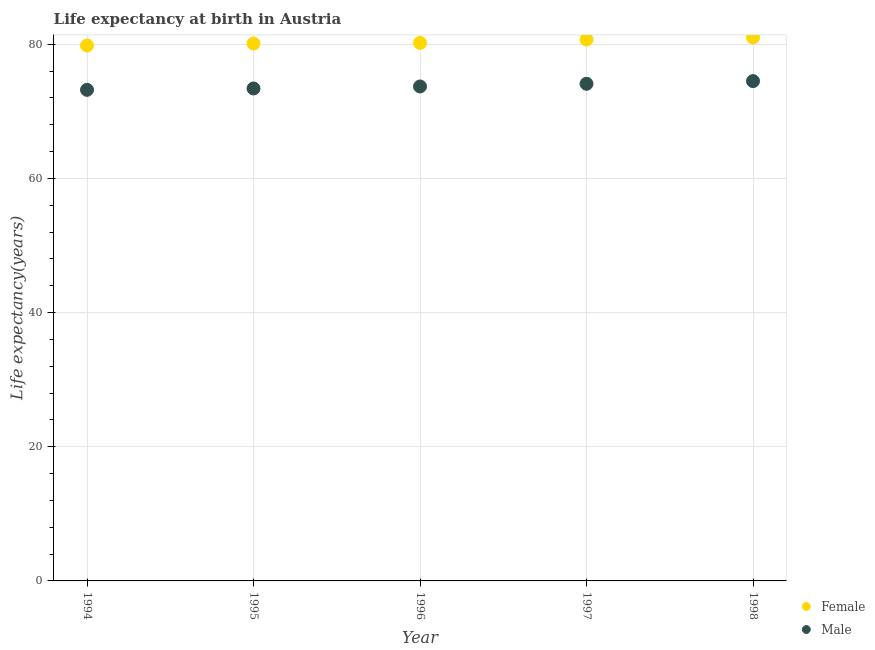How many different coloured dotlines are there?
Ensure brevity in your answer.  2. Across all years, what is the minimum life expectancy(female)?
Ensure brevity in your answer.  79.8. In which year was the life expectancy(female) maximum?
Ensure brevity in your answer.  1998. In which year was the life expectancy(male) minimum?
Offer a very short reply. 1994. What is the total life expectancy(male) in the graph?
Provide a succinct answer. 368.9. What is the difference between the life expectancy(male) in 1994 and that in 1995?
Provide a succinct answer. -0.2. What is the difference between the life expectancy(female) in 1997 and the life expectancy(male) in 1998?
Offer a very short reply. 6.2. What is the average life expectancy(female) per year?
Ensure brevity in your answer.  80.36. In the year 1995, what is the difference between the life expectancy(male) and life expectancy(female)?
Provide a short and direct response. -6.7. In how many years, is the life expectancy(male) greater than 4 years?
Ensure brevity in your answer.  5. What is the ratio of the life expectancy(male) in 1997 to that in 1998?
Offer a terse response. 0.99. What is the difference between the highest and the second highest life expectancy(male)?
Offer a very short reply. 0.4. What is the difference between the highest and the lowest life expectancy(male)?
Provide a succinct answer. 1.3. Does the life expectancy(female) monotonically increase over the years?
Give a very brief answer. Yes. Is the life expectancy(female) strictly greater than the life expectancy(male) over the years?
Offer a terse response. Yes. How many years are there in the graph?
Provide a succinct answer. 5. Are the values on the major ticks of Y-axis written in scientific E-notation?
Make the answer very short. No. Does the graph contain any zero values?
Offer a terse response. No. Does the graph contain grids?
Your answer should be very brief. Yes. Where does the legend appear in the graph?
Your answer should be compact. Bottom right. How many legend labels are there?
Your response must be concise. 2. What is the title of the graph?
Your response must be concise. Life expectancy at birth in Austria. What is the label or title of the Y-axis?
Give a very brief answer. Life expectancy(years). What is the Life expectancy(years) in Female in 1994?
Your answer should be very brief. 79.8. What is the Life expectancy(years) of Male in 1994?
Make the answer very short. 73.2. What is the Life expectancy(years) in Female in 1995?
Your answer should be very brief. 80.1. What is the Life expectancy(years) of Male in 1995?
Offer a very short reply. 73.4. What is the Life expectancy(years) of Female in 1996?
Give a very brief answer. 80.2. What is the Life expectancy(years) in Male in 1996?
Give a very brief answer. 73.7. What is the Life expectancy(years) in Female in 1997?
Make the answer very short. 80.7. What is the Life expectancy(years) in Male in 1997?
Provide a succinct answer. 74.1. What is the Life expectancy(years) of Male in 1998?
Ensure brevity in your answer.  74.5. Across all years, what is the maximum Life expectancy(years) in Male?
Make the answer very short. 74.5. Across all years, what is the minimum Life expectancy(years) of Female?
Give a very brief answer. 79.8. Across all years, what is the minimum Life expectancy(years) in Male?
Your answer should be very brief. 73.2. What is the total Life expectancy(years) in Female in the graph?
Make the answer very short. 401.8. What is the total Life expectancy(years) of Male in the graph?
Keep it short and to the point. 368.9. What is the difference between the Life expectancy(years) in Female in 1994 and that in 1995?
Offer a very short reply. -0.3. What is the difference between the Life expectancy(years) of Female in 1994 and that in 1997?
Keep it short and to the point. -0.9. What is the difference between the Life expectancy(years) in Male in 1994 and that in 1997?
Give a very brief answer. -0.9. What is the difference between the Life expectancy(years) of Male in 1995 and that in 1996?
Ensure brevity in your answer.  -0.3. What is the difference between the Life expectancy(years) in Female in 1995 and that in 1997?
Offer a terse response. -0.6. What is the difference between the Life expectancy(years) of Female in 1995 and that in 1998?
Provide a succinct answer. -0.9. What is the difference between the Life expectancy(years) in Female in 1997 and that in 1998?
Ensure brevity in your answer.  -0.3. What is the difference between the Life expectancy(years) in Female in 1994 and the Life expectancy(years) in Male in 1997?
Give a very brief answer. 5.7. What is the difference between the Life expectancy(years) of Female in 1994 and the Life expectancy(years) of Male in 1998?
Provide a short and direct response. 5.3. What is the difference between the Life expectancy(years) of Female in 1995 and the Life expectancy(years) of Male in 1996?
Ensure brevity in your answer.  6.4. What is the difference between the Life expectancy(years) of Female in 1996 and the Life expectancy(years) of Male in 1997?
Your response must be concise. 6.1. What is the difference between the Life expectancy(years) in Female in 1997 and the Life expectancy(years) in Male in 1998?
Provide a succinct answer. 6.2. What is the average Life expectancy(years) in Female per year?
Offer a very short reply. 80.36. What is the average Life expectancy(years) of Male per year?
Offer a very short reply. 73.78. In the year 1995, what is the difference between the Life expectancy(years) in Female and Life expectancy(years) in Male?
Your answer should be very brief. 6.7. In the year 1997, what is the difference between the Life expectancy(years) of Female and Life expectancy(years) of Male?
Offer a very short reply. 6.6. In the year 1998, what is the difference between the Life expectancy(years) of Female and Life expectancy(years) of Male?
Make the answer very short. 6.5. What is the ratio of the Life expectancy(years) of Female in 1994 to that in 1995?
Provide a short and direct response. 1. What is the ratio of the Life expectancy(years) in Male in 1994 to that in 1995?
Give a very brief answer. 1. What is the ratio of the Life expectancy(years) of Male in 1994 to that in 1996?
Your response must be concise. 0.99. What is the ratio of the Life expectancy(years) of Female in 1994 to that in 1997?
Keep it short and to the point. 0.99. What is the ratio of the Life expectancy(years) in Male in 1994 to that in 1997?
Make the answer very short. 0.99. What is the ratio of the Life expectancy(years) in Female in 1994 to that in 1998?
Ensure brevity in your answer.  0.99. What is the ratio of the Life expectancy(years) of Male in 1994 to that in 1998?
Ensure brevity in your answer.  0.98. What is the ratio of the Life expectancy(years) of Female in 1995 to that in 1996?
Ensure brevity in your answer.  1. What is the ratio of the Life expectancy(years) of Male in 1995 to that in 1996?
Offer a very short reply. 1. What is the ratio of the Life expectancy(years) of Female in 1995 to that in 1997?
Provide a succinct answer. 0.99. What is the ratio of the Life expectancy(years) in Male in 1995 to that in 1997?
Your answer should be compact. 0.99. What is the ratio of the Life expectancy(years) of Female in 1995 to that in 1998?
Provide a short and direct response. 0.99. What is the ratio of the Life expectancy(years) of Male in 1995 to that in 1998?
Offer a very short reply. 0.99. What is the ratio of the Life expectancy(years) in Female in 1996 to that in 1997?
Provide a succinct answer. 0.99. What is the ratio of the Life expectancy(years) in Male in 1996 to that in 1997?
Your response must be concise. 0.99. What is the ratio of the Life expectancy(years) of Female in 1996 to that in 1998?
Keep it short and to the point. 0.99. What is the ratio of the Life expectancy(years) in Male in 1996 to that in 1998?
Offer a very short reply. 0.99. What is the difference between the highest and the second highest Life expectancy(years) of Male?
Offer a terse response. 0.4. What is the difference between the highest and the lowest Life expectancy(years) of Female?
Your response must be concise. 1.2. What is the difference between the highest and the lowest Life expectancy(years) of Male?
Ensure brevity in your answer.  1.3. 